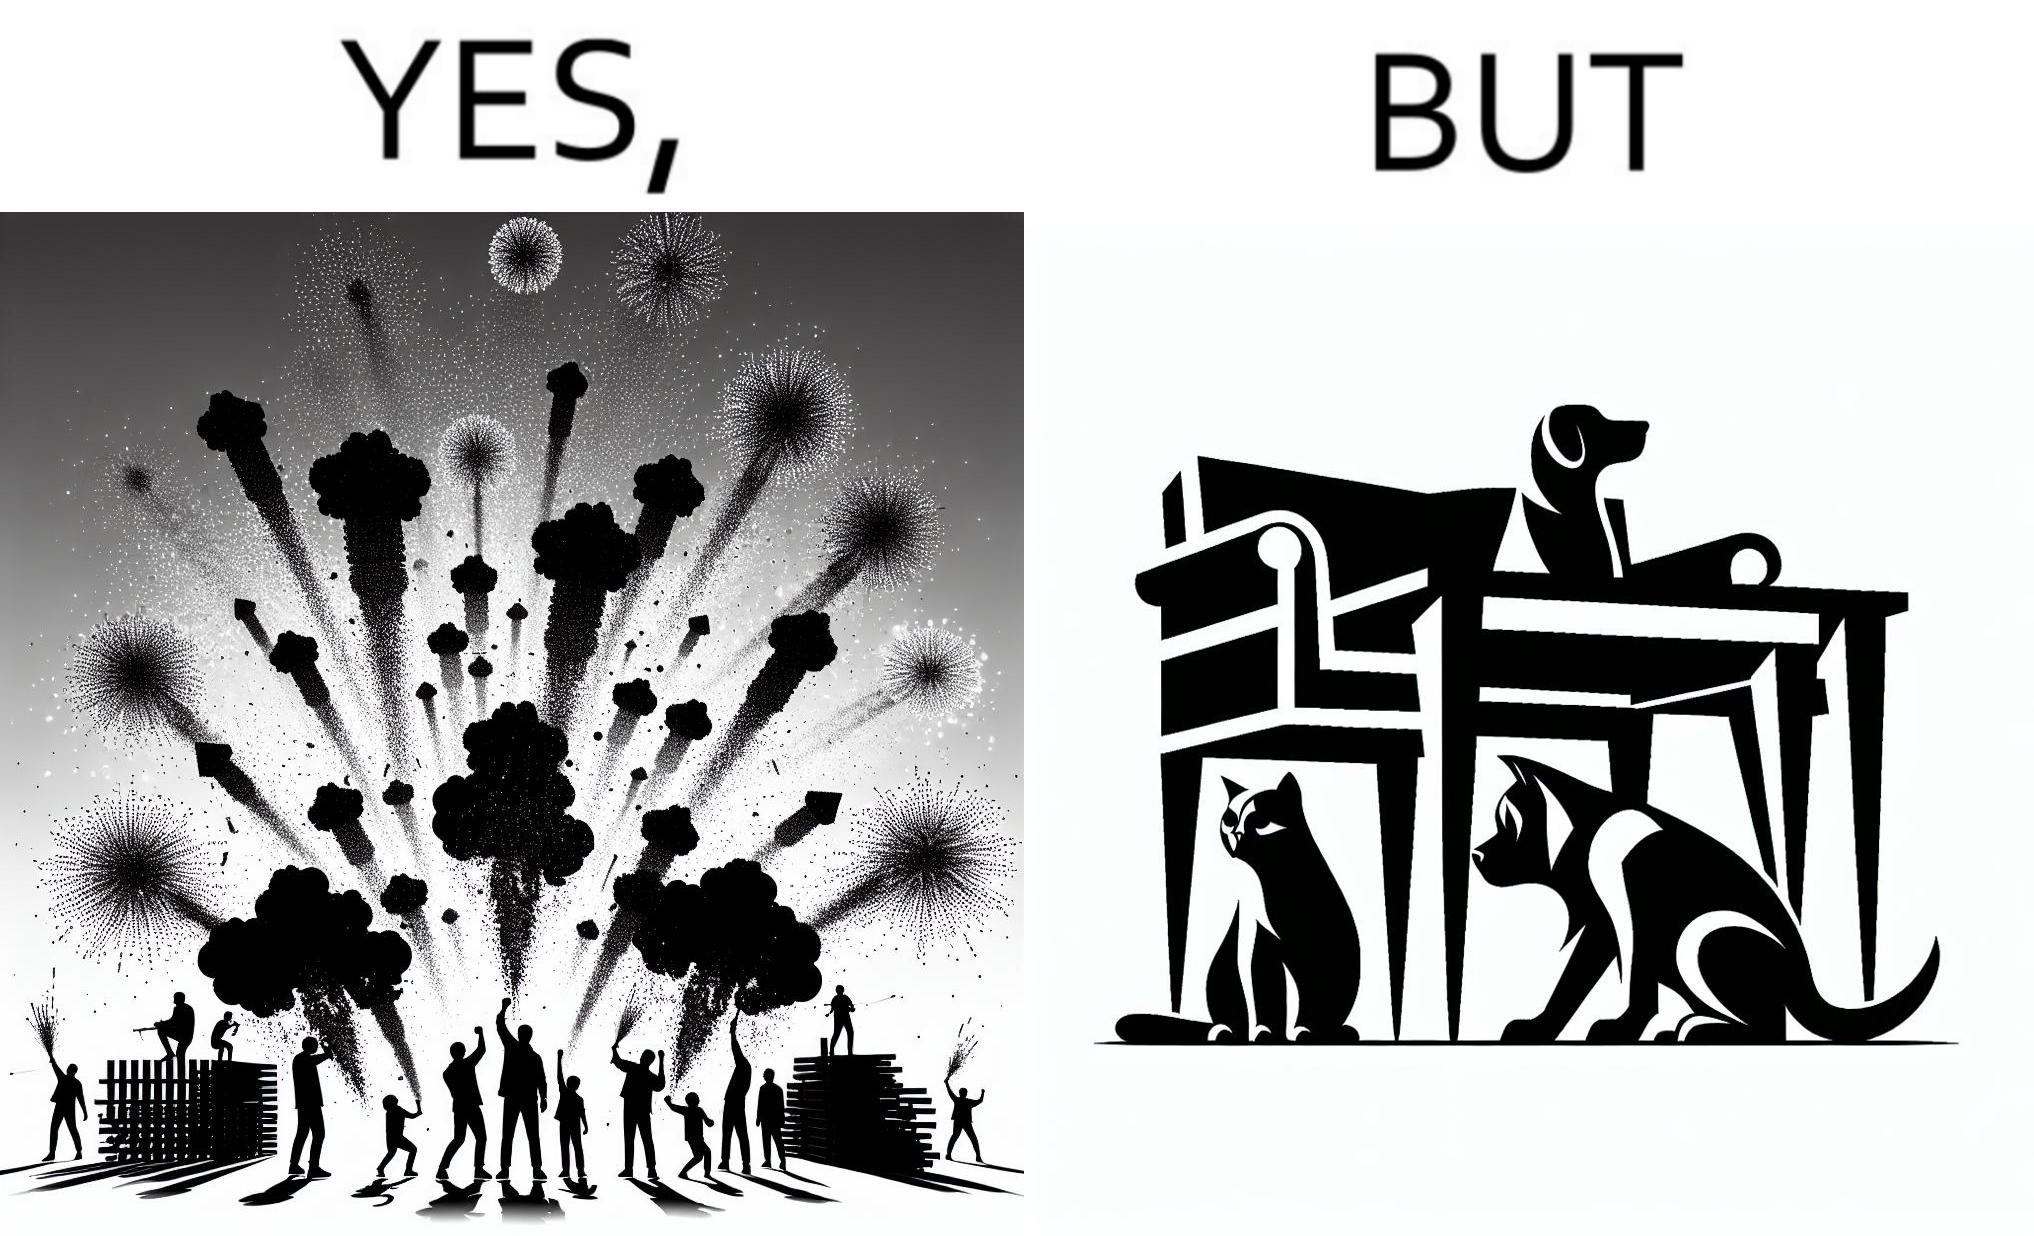What do you see in each half of this image? In the left part of the image: The image shows colorful firecrackers going off in the sky. In the right part of the image: The image shows two dogs and a cat hiding under furniture. 